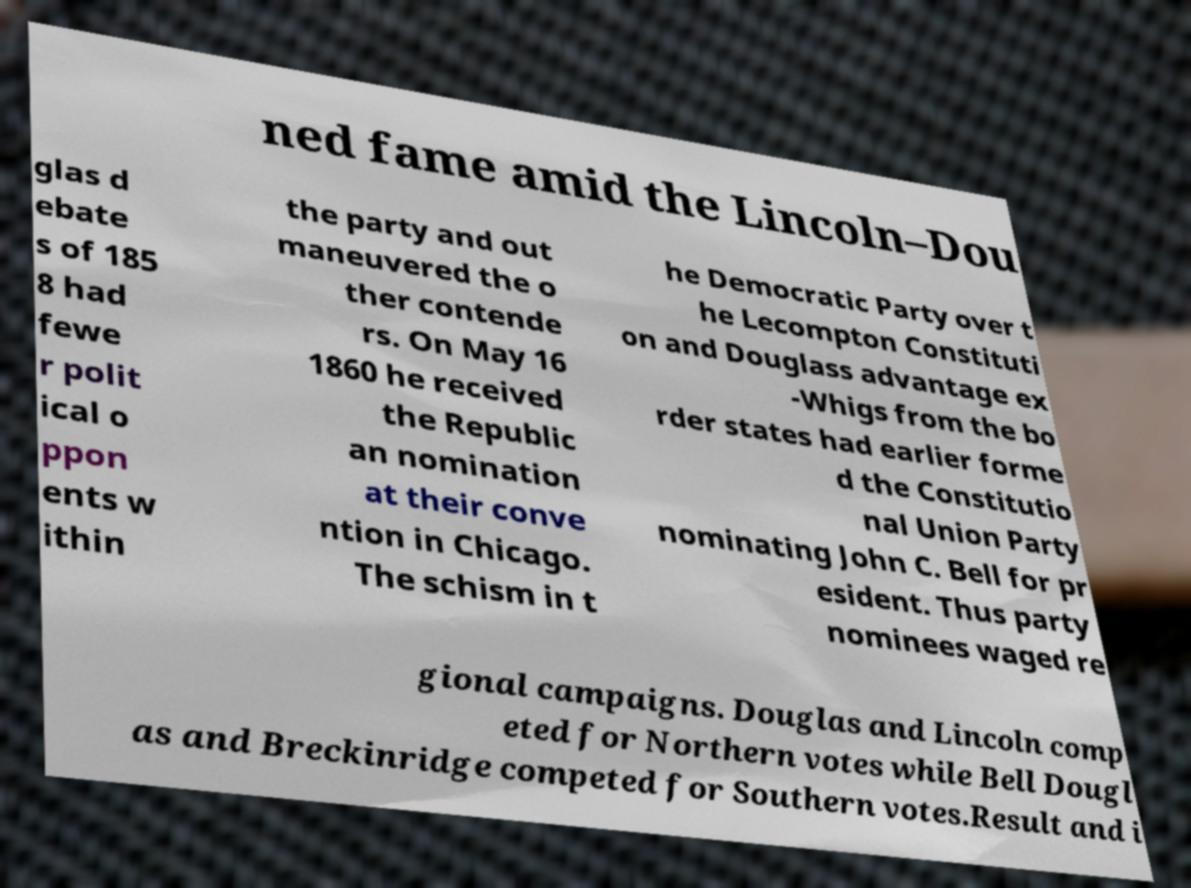Can you read and provide the text displayed in the image?This photo seems to have some interesting text. Can you extract and type it out for me? ned fame amid the Lincoln–Dou glas d ebate s of 185 8 had fewe r polit ical o ppon ents w ithin the party and out maneuvered the o ther contende rs. On May 16 1860 he received the Republic an nomination at their conve ntion in Chicago. The schism in t he Democratic Party over t he Lecompton Constituti on and Douglass advantage ex -Whigs from the bo rder states had earlier forme d the Constitutio nal Union Party nominating John C. Bell for pr esident. Thus party nominees waged re gional campaigns. Douglas and Lincoln comp eted for Northern votes while Bell Dougl as and Breckinridge competed for Southern votes.Result and i 